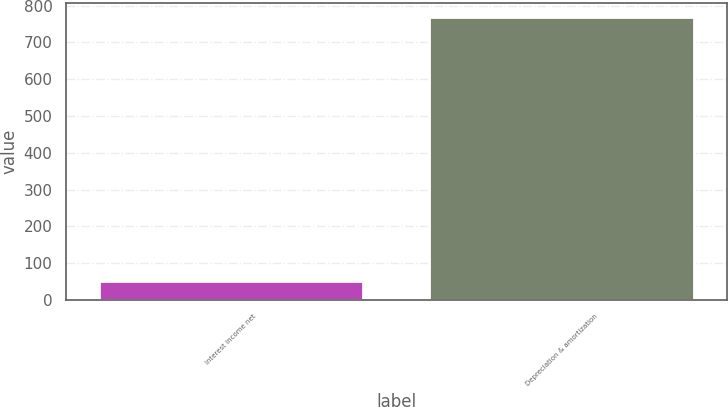<chart> <loc_0><loc_0><loc_500><loc_500><bar_chart><fcel>Interest income net<fcel>Depreciation & amortization<nl><fcel>52<fcel>770<nl></chart> 